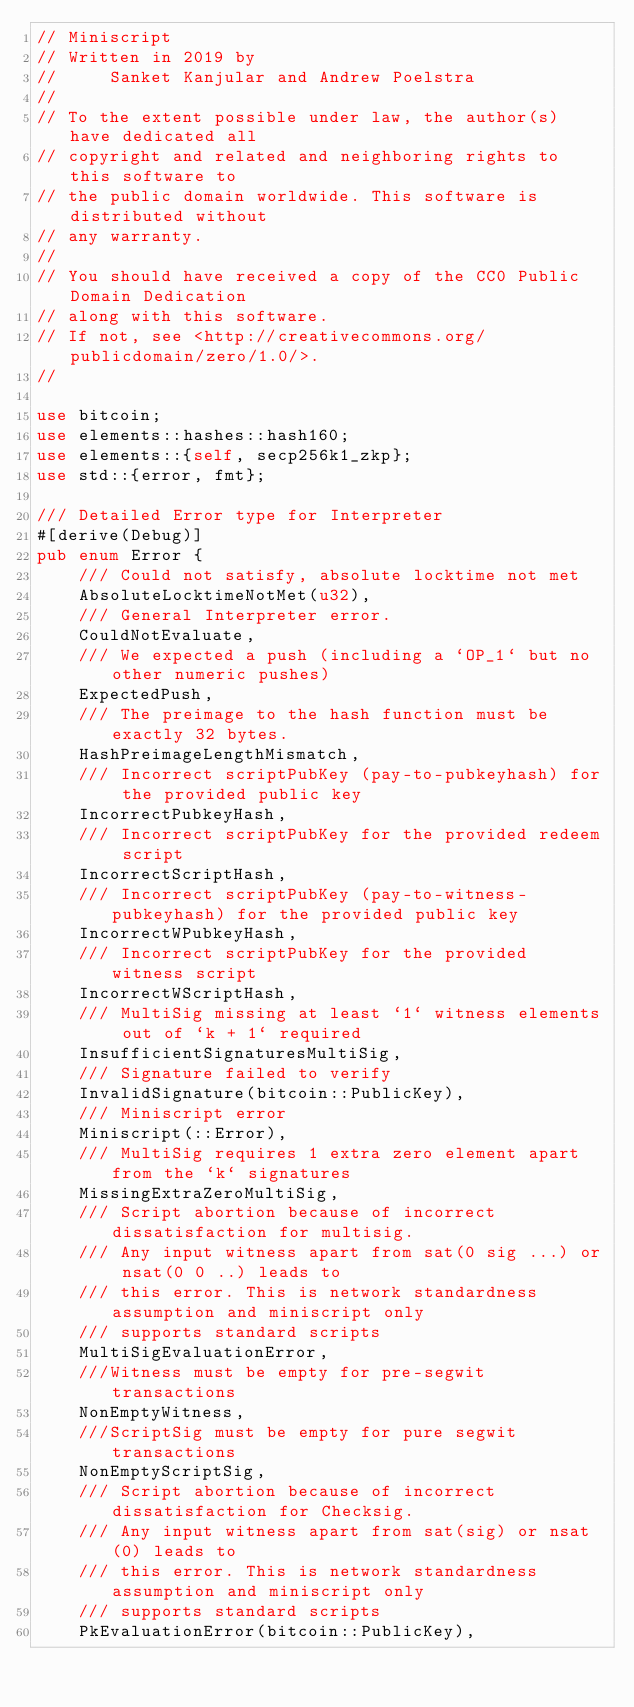Convert code to text. <code><loc_0><loc_0><loc_500><loc_500><_Rust_>// Miniscript
// Written in 2019 by
//     Sanket Kanjular and Andrew Poelstra
//
// To the extent possible under law, the author(s) have dedicated all
// copyright and related and neighboring rights to this software to
// the public domain worldwide. This software is distributed without
// any warranty.
//
// You should have received a copy of the CC0 Public Domain Dedication
// along with this software.
// If not, see <http://creativecommons.org/publicdomain/zero/1.0/>.
//

use bitcoin;
use elements::hashes::hash160;
use elements::{self, secp256k1_zkp};
use std::{error, fmt};

/// Detailed Error type for Interpreter
#[derive(Debug)]
pub enum Error {
    /// Could not satisfy, absolute locktime not met
    AbsoluteLocktimeNotMet(u32),
    /// General Interpreter error.
    CouldNotEvaluate,
    /// We expected a push (including a `OP_1` but no other numeric pushes)
    ExpectedPush,
    /// The preimage to the hash function must be exactly 32 bytes.
    HashPreimageLengthMismatch,
    /// Incorrect scriptPubKey (pay-to-pubkeyhash) for the provided public key
    IncorrectPubkeyHash,
    /// Incorrect scriptPubKey for the provided redeem script
    IncorrectScriptHash,
    /// Incorrect scriptPubKey (pay-to-witness-pubkeyhash) for the provided public key
    IncorrectWPubkeyHash,
    /// Incorrect scriptPubKey for the provided witness script
    IncorrectWScriptHash,
    /// MultiSig missing at least `1` witness elements out of `k + 1` required
    InsufficientSignaturesMultiSig,
    /// Signature failed to verify
    InvalidSignature(bitcoin::PublicKey),
    /// Miniscript error
    Miniscript(::Error),
    /// MultiSig requires 1 extra zero element apart from the `k` signatures
    MissingExtraZeroMultiSig,
    /// Script abortion because of incorrect dissatisfaction for multisig.
    /// Any input witness apart from sat(0 sig ...) or nsat(0 0 ..) leads to
    /// this error. This is network standardness assumption and miniscript only
    /// supports standard scripts
    MultiSigEvaluationError,
    ///Witness must be empty for pre-segwit transactions
    NonEmptyWitness,
    ///ScriptSig must be empty for pure segwit transactions
    NonEmptyScriptSig,
    /// Script abortion because of incorrect dissatisfaction for Checksig.
    /// Any input witness apart from sat(sig) or nsat(0) leads to
    /// this error. This is network standardness assumption and miniscript only
    /// supports standard scripts
    PkEvaluationError(bitcoin::PublicKey),</code> 